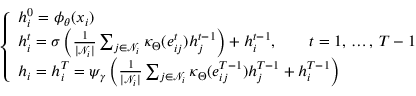Convert formula to latex. <formula><loc_0><loc_0><loc_500><loc_500>\begin{array} { r } { \left \{ \begin{array} { l l } { h _ { i } ^ { 0 } = \phi _ { \theta } ( x _ { i } ) } \\ { h _ { i } ^ { t } = \sigma \left ( \frac { 1 } { | \mathcal { N } _ { i } | } \sum _ { j \in \mathcal { N } _ { i } } \kappa _ { \Theta } ( e _ { i j } ^ { t } ) h _ { j } ^ { t - 1 } \right ) + h _ { i } ^ { t - 1 } , \quad t = 1 , \, \dots , \, T - 1 } \\ { h _ { i } = h _ { i } ^ { T } = \psi _ { \gamma } \left ( \frac { 1 } { | \mathcal { N } _ { i } | } \sum _ { j \in \mathcal { N } _ { i } } \kappa _ { \Theta } ( e _ { i j } ^ { T - 1 } ) h _ { j } ^ { T - 1 } + h _ { i } ^ { T - 1 } \right ) } \end{array} } \end{array}</formula> 